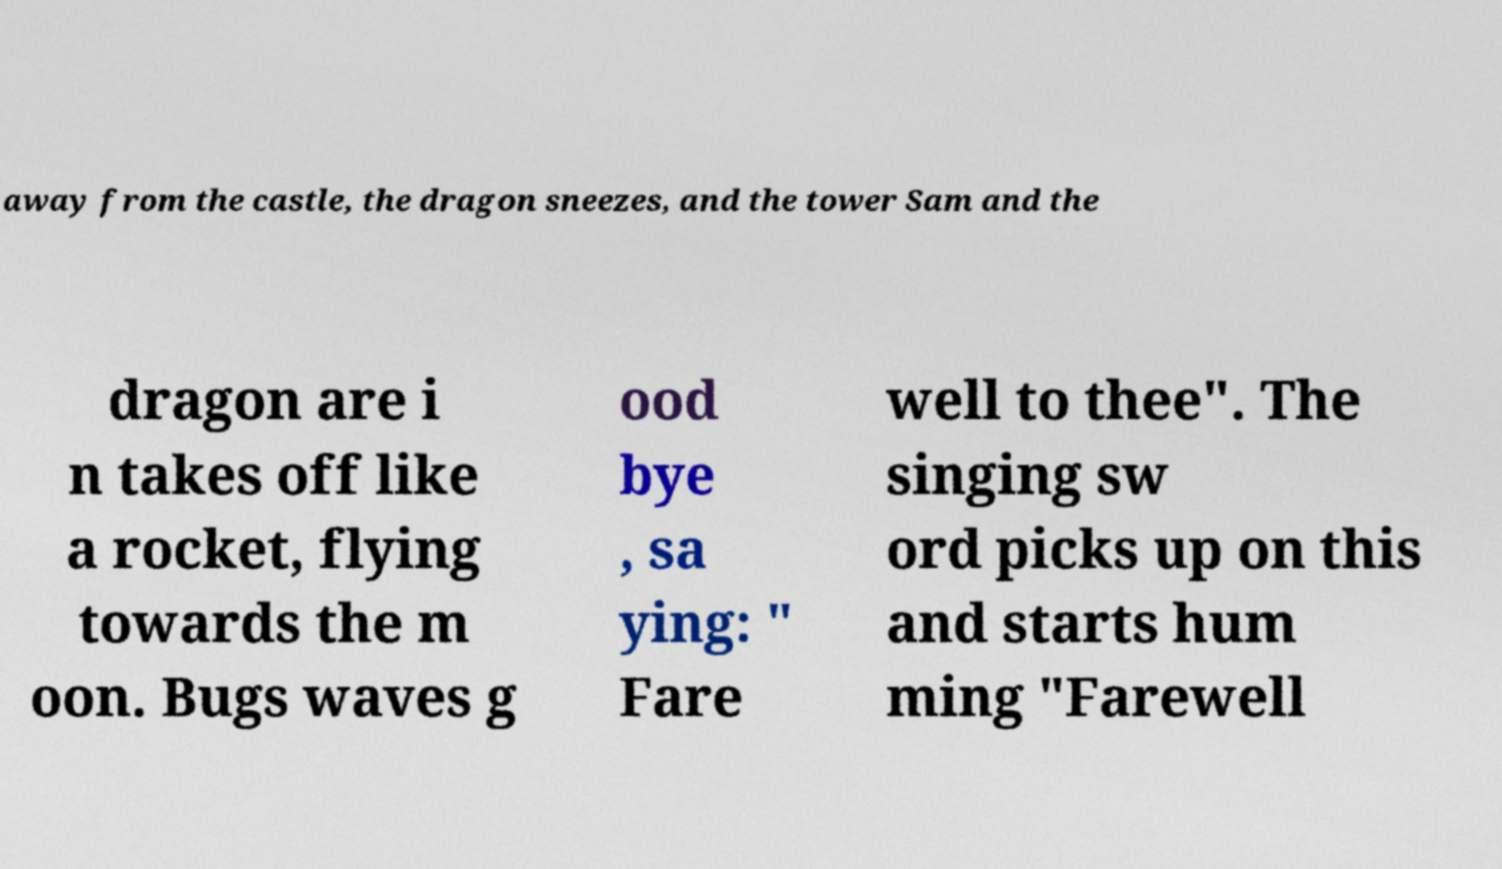Please identify and transcribe the text found in this image. away from the castle, the dragon sneezes, and the tower Sam and the dragon are i n takes off like a rocket, flying towards the m oon. Bugs waves g ood bye , sa ying: " Fare well to thee". The singing sw ord picks up on this and starts hum ming "Farewell 